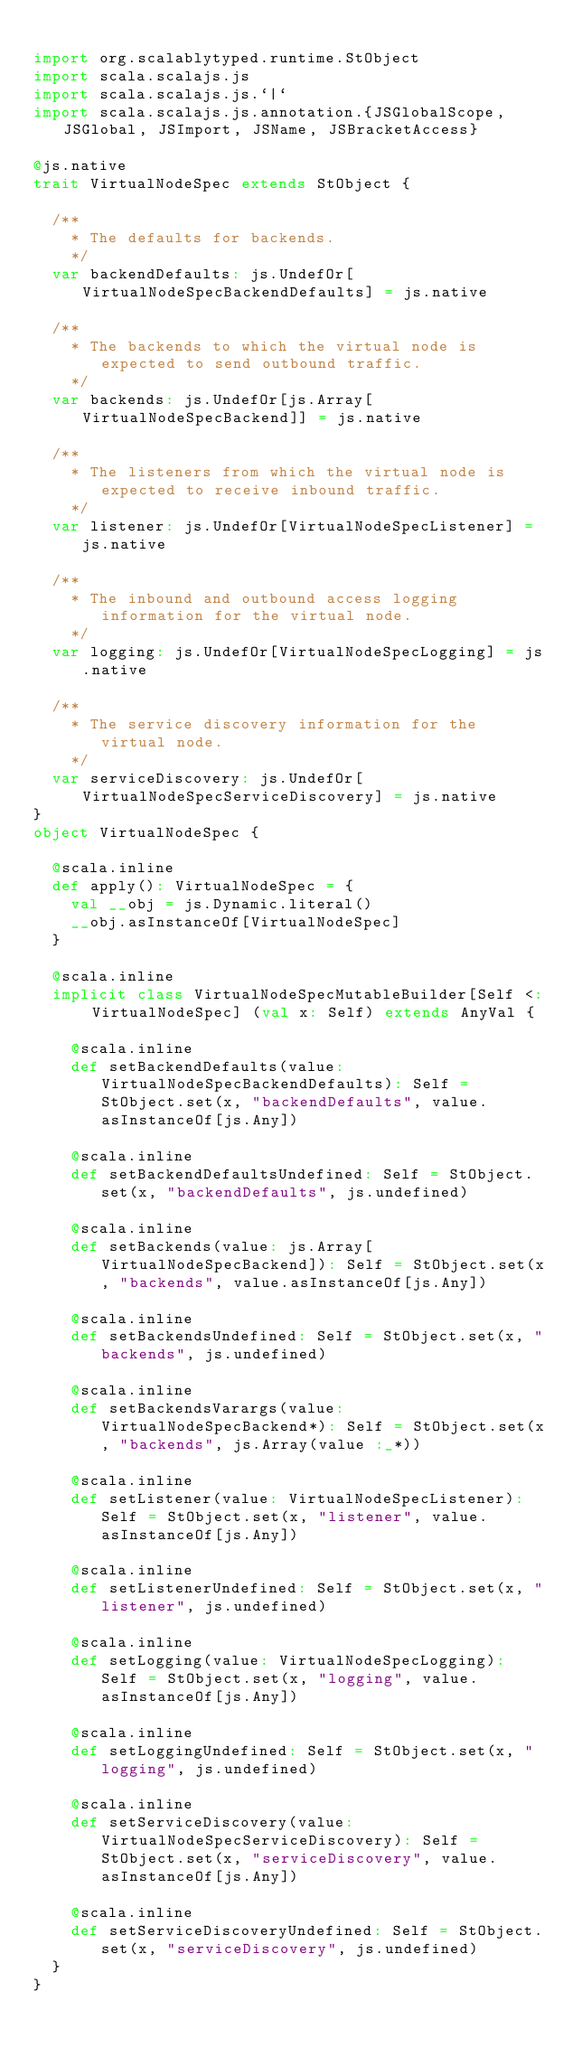<code> <loc_0><loc_0><loc_500><loc_500><_Scala_>
import org.scalablytyped.runtime.StObject
import scala.scalajs.js
import scala.scalajs.js.`|`
import scala.scalajs.js.annotation.{JSGlobalScope, JSGlobal, JSImport, JSName, JSBracketAccess}

@js.native
trait VirtualNodeSpec extends StObject {
  
  /**
    * The defaults for backends.
    */
  var backendDefaults: js.UndefOr[VirtualNodeSpecBackendDefaults] = js.native
  
  /**
    * The backends to which the virtual node is expected to send outbound traffic.
    */
  var backends: js.UndefOr[js.Array[VirtualNodeSpecBackend]] = js.native
  
  /**
    * The listeners from which the virtual node is expected to receive inbound traffic.
    */
  var listener: js.UndefOr[VirtualNodeSpecListener] = js.native
  
  /**
    * The inbound and outbound access logging information for the virtual node.
    */
  var logging: js.UndefOr[VirtualNodeSpecLogging] = js.native
  
  /**
    * The service discovery information for the virtual node.
    */
  var serviceDiscovery: js.UndefOr[VirtualNodeSpecServiceDiscovery] = js.native
}
object VirtualNodeSpec {
  
  @scala.inline
  def apply(): VirtualNodeSpec = {
    val __obj = js.Dynamic.literal()
    __obj.asInstanceOf[VirtualNodeSpec]
  }
  
  @scala.inline
  implicit class VirtualNodeSpecMutableBuilder[Self <: VirtualNodeSpec] (val x: Self) extends AnyVal {
    
    @scala.inline
    def setBackendDefaults(value: VirtualNodeSpecBackendDefaults): Self = StObject.set(x, "backendDefaults", value.asInstanceOf[js.Any])
    
    @scala.inline
    def setBackendDefaultsUndefined: Self = StObject.set(x, "backendDefaults", js.undefined)
    
    @scala.inline
    def setBackends(value: js.Array[VirtualNodeSpecBackend]): Self = StObject.set(x, "backends", value.asInstanceOf[js.Any])
    
    @scala.inline
    def setBackendsUndefined: Self = StObject.set(x, "backends", js.undefined)
    
    @scala.inline
    def setBackendsVarargs(value: VirtualNodeSpecBackend*): Self = StObject.set(x, "backends", js.Array(value :_*))
    
    @scala.inline
    def setListener(value: VirtualNodeSpecListener): Self = StObject.set(x, "listener", value.asInstanceOf[js.Any])
    
    @scala.inline
    def setListenerUndefined: Self = StObject.set(x, "listener", js.undefined)
    
    @scala.inline
    def setLogging(value: VirtualNodeSpecLogging): Self = StObject.set(x, "logging", value.asInstanceOf[js.Any])
    
    @scala.inline
    def setLoggingUndefined: Self = StObject.set(x, "logging", js.undefined)
    
    @scala.inline
    def setServiceDiscovery(value: VirtualNodeSpecServiceDiscovery): Self = StObject.set(x, "serviceDiscovery", value.asInstanceOf[js.Any])
    
    @scala.inline
    def setServiceDiscoveryUndefined: Self = StObject.set(x, "serviceDiscovery", js.undefined)
  }
}
</code> 